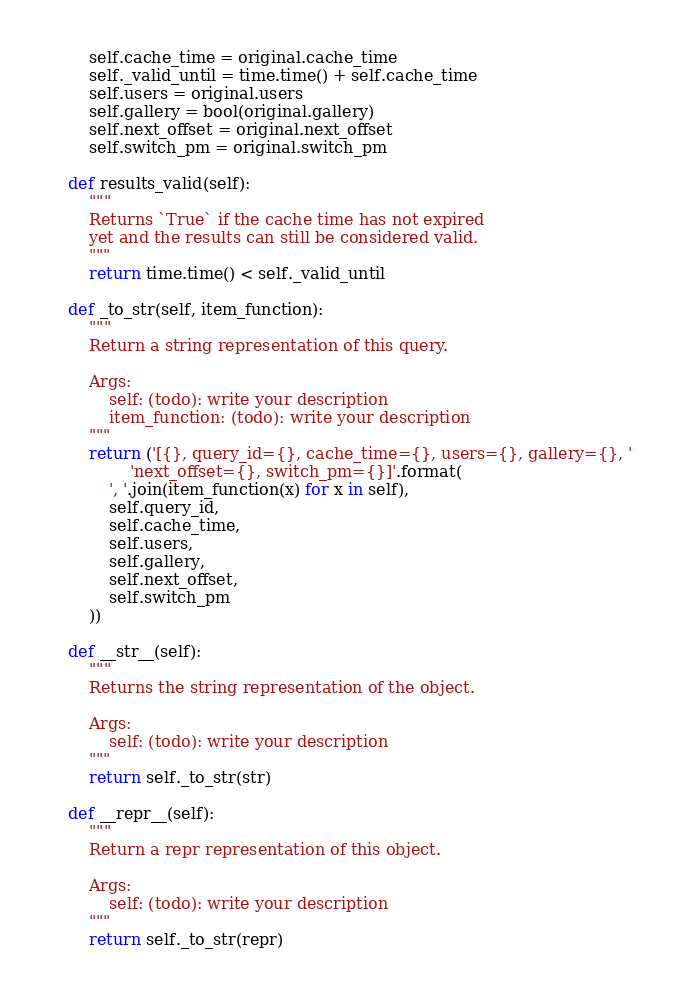<code> <loc_0><loc_0><loc_500><loc_500><_Python_>        self.cache_time = original.cache_time
        self._valid_until = time.time() + self.cache_time
        self.users = original.users
        self.gallery = bool(original.gallery)
        self.next_offset = original.next_offset
        self.switch_pm = original.switch_pm

    def results_valid(self):
        """
        Returns `True` if the cache time has not expired
        yet and the results can still be considered valid.
        """
        return time.time() < self._valid_until

    def _to_str(self, item_function):
        """
        Return a string representation of this query.

        Args:
            self: (todo): write your description
            item_function: (todo): write your description
        """
        return ('[{}, query_id={}, cache_time={}, users={}, gallery={}, '
                'next_offset={}, switch_pm={}]'.format(
            ', '.join(item_function(x) for x in self),
            self.query_id,
            self.cache_time,
            self.users,
            self.gallery,
            self.next_offset,
            self.switch_pm
        ))

    def __str__(self):
        """
        Returns the string representation of the object.

        Args:
            self: (todo): write your description
        """
        return self._to_str(str)

    def __repr__(self):
        """
        Return a repr representation of this object.

        Args:
            self: (todo): write your description
        """
        return self._to_str(repr)
</code> 